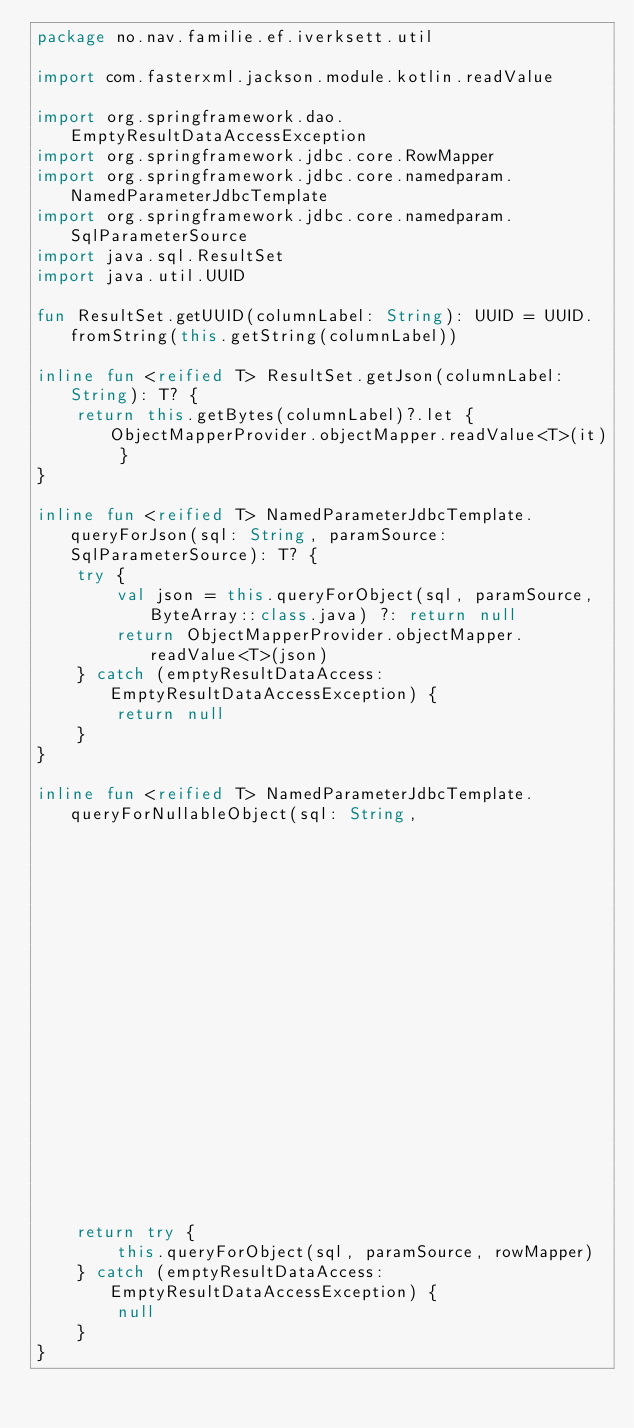<code> <loc_0><loc_0><loc_500><loc_500><_Kotlin_>package no.nav.familie.ef.iverksett.util

import com.fasterxml.jackson.module.kotlin.readValue

import org.springframework.dao.EmptyResultDataAccessException
import org.springframework.jdbc.core.RowMapper
import org.springframework.jdbc.core.namedparam.NamedParameterJdbcTemplate
import org.springframework.jdbc.core.namedparam.SqlParameterSource
import java.sql.ResultSet
import java.util.UUID

fun ResultSet.getUUID(columnLabel: String): UUID = UUID.fromString(this.getString(columnLabel))

inline fun <reified T> ResultSet.getJson(columnLabel: String): T? {
    return this.getBytes(columnLabel)?.let { ObjectMapperProvider.objectMapper.readValue<T>(it) }
}

inline fun <reified T> NamedParameterJdbcTemplate.queryForJson(sql: String, paramSource: SqlParameterSource): T? {
    try {
        val json = this.queryForObject(sql, paramSource, ByteArray::class.java) ?: return null
        return ObjectMapperProvider.objectMapper.readValue<T>(json)
    } catch (emptyResultDataAccess: EmptyResultDataAccessException) {
        return null
    }
}

inline fun <reified T> NamedParameterJdbcTemplate.queryForNullableObject(sql: String,
                                                                         paramSource: SqlParameterSource,
                                                                         rowMapper: RowMapper<T>): T? {
    return try {
        this.queryForObject(sql, paramSource, rowMapper)
    } catch (emptyResultDataAccess: EmptyResultDataAccessException) {
        null
    }
}

</code> 